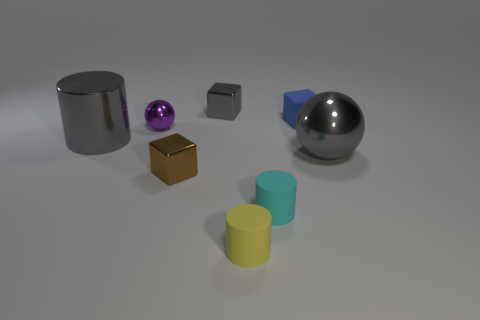Subtract all small matte cubes. How many cubes are left? 2 Subtract all blue blocks. How many blocks are left? 2 Subtract 1 cubes. How many cubes are left? 2 Subtract all cylinders. How many objects are left? 5 Add 7 big gray spheres. How many big gray spheres are left? 8 Add 4 purple things. How many purple things exist? 5 Add 1 big shiny cylinders. How many objects exist? 9 Subtract 0 blue spheres. How many objects are left? 8 Subtract all purple cylinders. Subtract all yellow balls. How many cylinders are left? 3 Subtract all brown cylinders. How many gray spheres are left? 1 